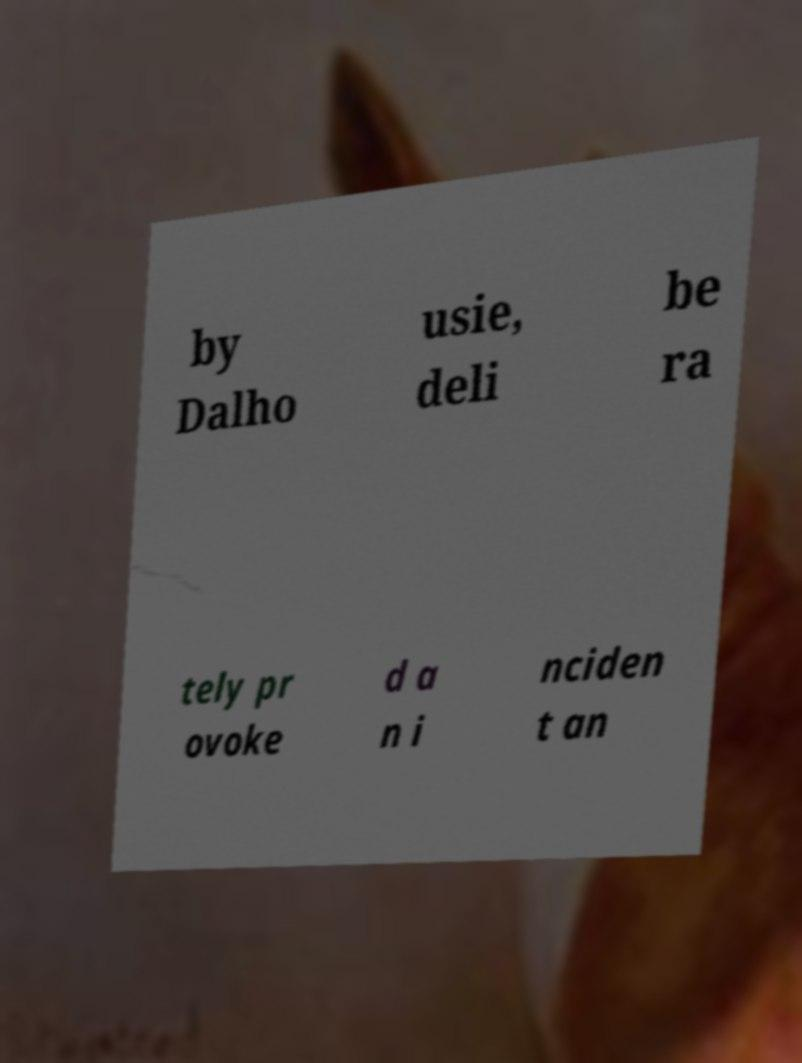Can you read and provide the text displayed in the image?This photo seems to have some interesting text. Can you extract and type it out for me? by Dalho usie, deli be ra tely pr ovoke d a n i nciden t an 